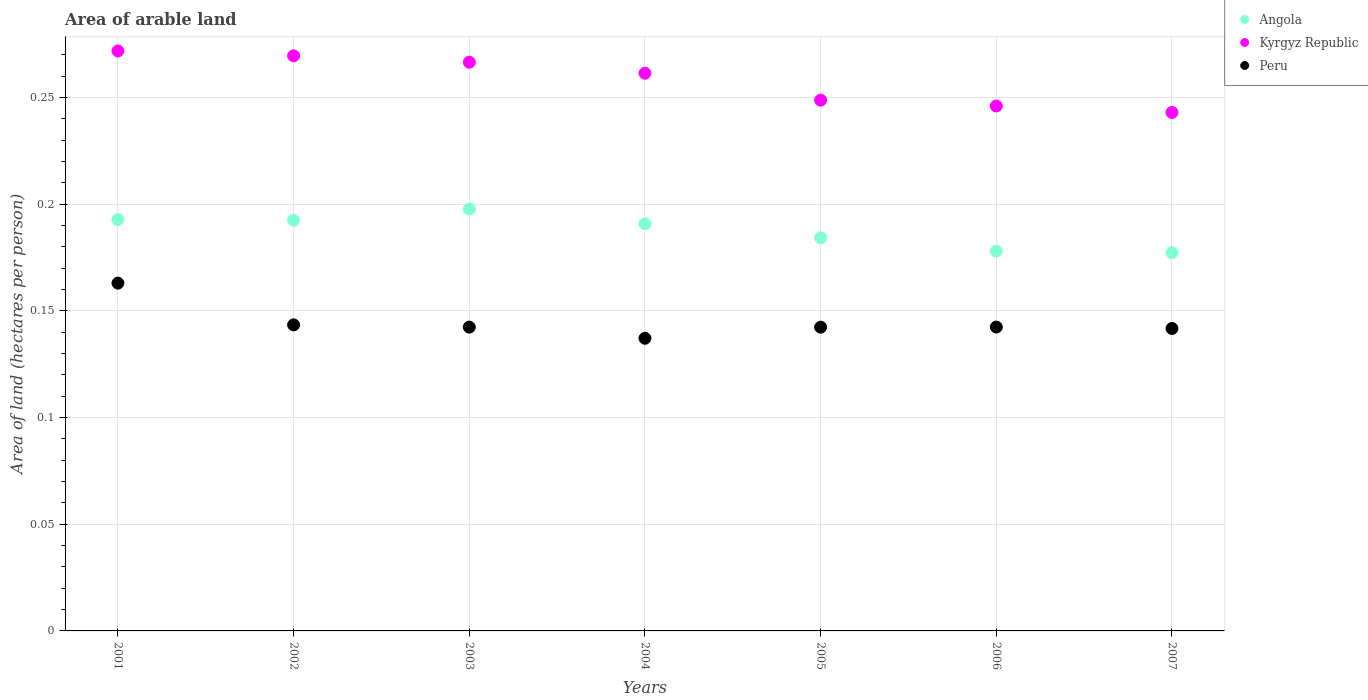What is the total arable land in Angola in 2007?
Offer a very short reply. 0.18. Across all years, what is the maximum total arable land in Peru?
Offer a terse response. 0.16. Across all years, what is the minimum total arable land in Kyrgyz Republic?
Ensure brevity in your answer.  0.24. What is the total total arable land in Angola in the graph?
Offer a very short reply. 1.31. What is the difference between the total arable land in Peru in 2002 and that in 2007?
Your answer should be compact. 0. What is the difference between the total arable land in Peru in 2006 and the total arable land in Kyrgyz Republic in 2005?
Offer a terse response. -0.11. What is the average total arable land in Kyrgyz Republic per year?
Keep it short and to the point. 0.26. In the year 2004, what is the difference between the total arable land in Kyrgyz Republic and total arable land in Angola?
Provide a short and direct response. 0.07. What is the ratio of the total arable land in Kyrgyz Republic in 2005 to that in 2006?
Your response must be concise. 1.01. What is the difference between the highest and the second highest total arable land in Kyrgyz Republic?
Your answer should be very brief. 0. What is the difference between the highest and the lowest total arable land in Kyrgyz Republic?
Your answer should be compact. 0.03. Is the sum of the total arable land in Angola in 2002 and 2004 greater than the maximum total arable land in Kyrgyz Republic across all years?
Give a very brief answer. Yes. Does the total arable land in Kyrgyz Republic monotonically increase over the years?
Your response must be concise. No. Is the total arable land in Peru strictly greater than the total arable land in Kyrgyz Republic over the years?
Keep it short and to the point. No. Is the total arable land in Angola strictly less than the total arable land in Kyrgyz Republic over the years?
Keep it short and to the point. Yes. Does the graph contain grids?
Your answer should be compact. Yes. Where does the legend appear in the graph?
Make the answer very short. Top right. How many legend labels are there?
Ensure brevity in your answer.  3. What is the title of the graph?
Offer a very short reply. Area of arable land. What is the label or title of the X-axis?
Provide a short and direct response. Years. What is the label or title of the Y-axis?
Ensure brevity in your answer.  Area of land (hectares per person). What is the Area of land (hectares per person) in Angola in 2001?
Your response must be concise. 0.19. What is the Area of land (hectares per person) of Kyrgyz Republic in 2001?
Give a very brief answer. 0.27. What is the Area of land (hectares per person) of Peru in 2001?
Ensure brevity in your answer.  0.16. What is the Area of land (hectares per person) of Angola in 2002?
Ensure brevity in your answer.  0.19. What is the Area of land (hectares per person) of Kyrgyz Republic in 2002?
Your answer should be very brief. 0.27. What is the Area of land (hectares per person) of Peru in 2002?
Provide a short and direct response. 0.14. What is the Area of land (hectares per person) of Angola in 2003?
Your answer should be very brief. 0.2. What is the Area of land (hectares per person) in Kyrgyz Republic in 2003?
Your response must be concise. 0.27. What is the Area of land (hectares per person) of Peru in 2003?
Your response must be concise. 0.14. What is the Area of land (hectares per person) of Angola in 2004?
Keep it short and to the point. 0.19. What is the Area of land (hectares per person) of Kyrgyz Republic in 2004?
Your answer should be compact. 0.26. What is the Area of land (hectares per person) in Peru in 2004?
Ensure brevity in your answer.  0.14. What is the Area of land (hectares per person) in Angola in 2005?
Give a very brief answer. 0.18. What is the Area of land (hectares per person) of Kyrgyz Republic in 2005?
Provide a succinct answer. 0.25. What is the Area of land (hectares per person) of Peru in 2005?
Your answer should be compact. 0.14. What is the Area of land (hectares per person) of Angola in 2006?
Provide a succinct answer. 0.18. What is the Area of land (hectares per person) in Kyrgyz Republic in 2006?
Provide a short and direct response. 0.25. What is the Area of land (hectares per person) in Peru in 2006?
Keep it short and to the point. 0.14. What is the Area of land (hectares per person) in Angola in 2007?
Provide a succinct answer. 0.18. What is the Area of land (hectares per person) in Kyrgyz Republic in 2007?
Your answer should be very brief. 0.24. What is the Area of land (hectares per person) in Peru in 2007?
Provide a short and direct response. 0.14. Across all years, what is the maximum Area of land (hectares per person) of Angola?
Your answer should be compact. 0.2. Across all years, what is the maximum Area of land (hectares per person) of Kyrgyz Republic?
Your response must be concise. 0.27. Across all years, what is the maximum Area of land (hectares per person) of Peru?
Your response must be concise. 0.16. Across all years, what is the minimum Area of land (hectares per person) of Angola?
Ensure brevity in your answer.  0.18. Across all years, what is the minimum Area of land (hectares per person) in Kyrgyz Republic?
Offer a very short reply. 0.24. Across all years, what is the minimum Area of land (hectares per person) in Peru?
Keep it short and to the point. 0.14. What is the total Area of land (hectares per person) of Angola in the graph?
Ensure brevity in your answer.  1.31. What is the total Area of land (hectares per person) of Kyrgyz Republic in the graph?
Ensure brevity in your answer.  1.81. What is the total Area of land (hectares per person) in Peru in the graph?
Ensure brevity in your answer.  1.01. What is the difference between the Area of land (hectares per person) in Kyrgyz Republic in 2001 and that in 2002?
Offer a very short reply. 0. What is the difference between the Area of land (hectares per person) in Peru in 2001 and that in 2002?
Your answer should be compact. 0.02. What is the difference between the Area of land (hectares per person) in Angola in 2001 and that in 2003?
Give a very brief answer. -0. What is the difference between the Area of land (hectares per person) of Kyrgyz Republic in 2001 and that in 2003?
Make the answer very short. 0.01. What is the difference between the Area of land (hectares per person) of Peru in 2001 and that in 2003?
Provide a short and direct response. 0.02. What is the difference between the Area of land (hectares per person) of Angola in 2001 and that in 2004?
Keep it short and to the point. 0. What is the difference between the Area of land (hectares per person) in Kyrgyz Republic in 2001 and that in 2004?
Your response must be concise. 0.01. What is the difference between the Area of land (hectares per person) in Peru in 2001 and that in 2004?
Provide a short and direct response. 0.03. What is the difference between the Area of land (hectares per person) of Angola in 2001 and that in 2005?
Your response must be concise. 0.01. What is the difference between the Area of land (hectares per person) of Kyrgyz Republic in 2001 and that in 2005?
Ensure brevity in your answer.  0.02. What is the difference between the Area of land (hectares per person) of Peru in 2001 and that in 2005?
Your answer should be compact. 0.02. What is the difference between the Area of land (hectares per person) of Angola in 2001 and that in 2006?
Give a very brief answer. 0.01. What is the difference between the Area of land (hectares per person) of Kyrgyz Republic in 2001 and that in 2006?
Ensure brevity in your answer.  0.03. What is the difference between the Area of land (hectares per person) in Peru in 2001 and that in 2006?
Offer a very short reply. 0.02. What is the difference between the Area of land (hectares per person) of Angola in 2001 and that in 2007?
Offer a very short reply. 0.02. What is the difference between the Area of land (hectares per person) of Kyrgyz Republic in 2001 and that in 2007?
Offer a very short reply. 0.03. What is the difference between the Area of land (hectares per person) in Peru in 2001 and that in 2007?
Provide a succinct answer. 0.02. What is the difference between the Area of land (hectares per person) in Angola in 2002 and that in 2003?
Keep it short and to the point. -0.01. What is the difference between the Area of land (hectares per person) of Kyrgyz Republic in 2002 and that in 2003?
Make the answer very short. 0. What is the difference between the Area of land (hectares per person) of Angola in 2002 and that in 2004?
Offer a very short reply. 0. What is the difference between the Area of land (hectares per person) of Kyrgyz Republic in 2002 and that in 2004?
Your answer should be compact. 0.01. What is the difference between the Area of land (hectares per person) in Peru in 2002 and that in 2004?
Offer a terse response. 0.01. What is the difference between the Area of land (hectares per person) of Angola in 2002 and that in 2005?
Your answer should be very brief. 0.01. What is the difference between the Area of land (hectares per person) of Kyrgyz Republic in 2002 and that in 2005?
Your answer should be very brief. 0.02. What is the difference between the Area of land (hectares per person) in Peru in 2002 and that in 2005?
Offer a very short reply. 0. What is the difference between the Area of land (hectares per person) of Angola in 2002 and that in 2006?
Keep it short and to the point. 0.01. What is the difference between the Area of land (hectares per person) in Kyrgyz Republic in 2002 and that in 2006?
Your response must be concise. 0.02. What is the difference between the Area of land (hectares per person) in Angola in 2002 and that in 2007?
Make the answer very short. 0.02. What is the difference between the Area of land (hectares per person) in Kyrgyz Republic in 2002 and that in 2007?
Give a very brief answer. 0.03. What is the difference between the Area of land (hectares per person) of Peru in 2002 and that in 2007?
Your answer should be very brief. 0. What is the difference between the Area of land (hectares per person) of Angola in 2003 and that in 2004?
Provide a short and direct response. 0.01. What is the difference between the Area of land (hectares per person) of Kyrgyz Republic in 2003 and that in 2004?
Provide a short and direct response. 0.01. What is the difference between the Area of land (hectares per person) of Peru in 2003 and that in 2004?
Make the answer very short. 0.01. What is the difference between the Area of land (hectares per person) in Angola in 2003 and that in 2005?
Your answer should be compact. 0.01. What is the difference between the Area of land (hectares per person) of Kyrgyz Republic in 2003 and that in 2005?
Your answer should be very brief. 0.02. What is the difference between the Area of land (hectares per person) of Angola in 2003 and that in 2006?
Your answer should be very brief. 0.02. What is the difference between the Area of land (hectares per person) in Kyrgyz Republic in 2003 and that in 2006?
Ensure brevity in your answer.  0.02. What is the difference between the Area of land (hectares per person) in Angola in 2003 and that in 2007?
Your answer should be very brief. 0.02. What is the difference between the Area of land (hectares per person) of Kyrgyz Republic in 2003 and that in 2007?
Offer a terse response. 0.02. What is the difference between the Area of land (hectares per person) of Peru in 2003 and that in 2007?
Give a very brief answer. 0. What is the difference between the Area of land (hectares per person) of Angola in 2004 and that in 2005?
Make the answer very short. 0.01. What is the difference between the Area of land (hectares per person) of Kyrgyz Republic in 2004 and that in 2005?
Keep it short and to the point. 0.01. What is the difference between the Area of land (hectares per person) of Peru in 2004 and that in 2005?
Offer a very short reply. -0.01. What is the difference between the Area of land (hectares per person) of Angola in 2004 and that in 2006?
Ensure brevity in your answer.  0.01. What is the difference between the Area of land (hectares per person) in Kyrgyz Republic in 2004 and that in 2006?
Your answer should be very brief. 0.02. What is the difference between the Area of land (hectares per person) of Peru in 2004 and that in 2006?
Your answer should be very brief. -0.01. What is the difference between the Area of land (hectares per person) of Angola in 2004 and that in 2007?
Your answer should be compact. 0.01. What is the difference between the Area of land (hectares per person) in Kyrgyz Republic in 2004 and that in 2007?
Provide a succinct answer. 0.02. What is the difference between the Area of land (hectares per person) in Peru in 2004 and that in 2007?
Keep it short and to the point. -0. What is the difference between the Area of land (hectares per person) of Angola in 2005 and that in 2006?
Your response must be concise. 0.01. What is the difference between the Area of land (hectares per person) in Kyrgyz Republic in 2005 and that in 2006?
Your response must be concise. 0. What is the difference between the Area of land (hectares per person) in Peru in 2005 and that in 2006?
Make the answer very short. -0. What is the difference between the Area of land (hectares per person) in Angola in 2005 and that in 2007?
Provide a succinct answer. 0.01. What is the difference between the Area of land (hectares per person) in Kyrgyz Republic in 2005 and that in 2007?
Your answer should be compact. 0.01. What is the difference between the Area of land (hectares per person) in Peru in 2005 and that in 2007?
Your answer should be compact. 0. What is the difference between the Area of land (hectares per person) of Angola in 2006 and that in 2007?
Your answer should be very brief. 0. What is the difference between the Area of land (hectares per person) of Kyrgyz Republic in 2006 and that in 2007?
Offer a very short reply. 0. What is the difference between the Area of land (hectares per person) in Peru in 2006 and that in 2007?
Offer a terse response. 0. What is the difference between the Area of land (hectares per person) in Angola in 2001 and the Area of land (hectares per person) in Kyrgyz Republic in 2002?
Offer a terse response. -0.08. What is the difference between the Area of land (hectares per person) of Angola in 2001 and the Area of land (hectares per person) of Peru in 2002?
Give a very brief answer. 0.05. What is the difference between the Area of land (hectares per person) of Kyrgyz Republic in 2001 and the Area of land (hectares per person) of Peru in 2002?
Keep it short and to the point. 0.13. What is the difference between the Area of land (hectares per person) in Angola in 2001 and the Area of land (hectares per person) in Kyrgyz Republic in 2003?
Provide a short and direct response. -0.07. What is the difference between the Area of land (hectares per person) in Angola in 2001 and the Area of land (hectares per person) in Peru in 2003?
Keep it short and to the point. 0.05. What is the difference between the Area of land (hectares per person) in Kyrgyz Republic in 2001 and the Area of land (hectares per person) in Peru in 2003?
Your response must be concise. 0.13. What is the difference between the Area of land (hectares per person) in Angola in 2001 and the Area of land (hectares per person) in Kyrgyz Republic in 2004?
Offer a terse response. -0.07. What is the difference between the Area of land (hectares per person) of Angola in 2001 and the Area of land (hectares per person) of Peru in 2004?
Ensure brevity in your answer.  0.06. What is the difference between the Area of land (hectares per person) in Kyrgyz Republic in 2001 and the Area of land (hectares per person) in Peru in 2004?
Your response must be concise. 0.13. What is the difference between the Area of land (hectares per person) in Angola in 2001 and the Area of land (hectares per person) in Kyrgyz Republic in 2005?
Your response must be concise. -0.06. What is the difference between the Area of land (hectares per person) in Angola in 2001 and the Area of land (hectares per person) in Peru in 2005?
Provide a succinct answer. 0.05. What is the difference between the Area of land (hectares per person) in Kyrgyz Republic in 2001 and the Area of land (hectares per person) in Peru in 2005?
Make the answer very short. 0.13. What is the difference between the Area of land (hectares per person) of Angola in 2001 and the Area of land (hectares per person) of Kyrgyz Republic in 2006?
Provide a short and direct response. -0.05. What is the difference between the Area of land (hectares per person) of Angola in 2001 and the Area of land (hectares per person) of Peru in 2006?
Your answer should be compact. 0.05. What is the difference between the Area of land (hectares per person) of Kyrgyz Republic in 2001 and the Area of land (hectares per person) of Peru in 2006?
Provide a short and direct response. 0.13. What is the difference between the Area of land (hectares per person) in Angola in 2001 and the Area of land (hectares per person) in Kyrgyz Republic in 2007?
Provide a succinct answer. -0.05. What is the difference between the Area of land (hectares per person) of Angola in 2001 and the Area of land (hectares per person) of Peru in 2007?
Provide a short and direct response. 0.05. What is the difference between the Area of land (hectares per person) of Kyrgyz Republic in 2001 and the Area of land (hectares per person) of Peru in 2007?
Your response must be concise. 0.13. What is the difference between the Area of land (hectares per person) of Angola in 2002 and the Area of land (hectares per person) of Kyrgyz Republic in 2003?
Give a very brief answer. -0.07. What is the difference between the Area of land (hectares per person) of Angola in 2002 and the Area of land (hectares per person) of Peru in 2003?
Ensure brevity in your answer.  0.05. What is the difference between the Area of land (hectares per person) in Kyrgyz Republic in 2002 and the Area of land (hectares per person) in Peru in 2003?
Offer a very short reply. 0.13. What is the difference between the Area of land (hectares per person) in Angola in 2002 and the Area of land (hectares per person) in Kyrgyz Republic in 2004?
Your response must be concise. -0.07. What is the difference between the Area of land (hectares per person) in Angola in 2002 and the Area of land (hectares per person) in Peru in 2004?
Offer a terse response. 0.06. What is the difference between the Area of land (hectares per person) of Kyrgyz Republic in 2002 and the Area of land (hectares per person) of Peru in 2004?
Offer a very short reply. 0.13. What is the difference between the Area of land (hectares per person) in Angola in 2002 and the Area of land (hectares per person) in Kyrgyz Republic in 2005?
Provide a short and direct response. -0.06. What is the difference between the Area of land (hectares per person) of Angola in 2002 and the Area of land (hectares per person) of Peru in 2005?
Your answer should be very brief. 0.05. What is the difference between the Area of land (hectares per person) in Kyrgyz Republic in 2002 and the Area of land (hectares per person) in Peru in 2005?
Offer a very short reply. 0.13. What is the difference between the Area of land (hectares per person) of Angola in 2002 and the Area of land (hectares per person) of Kyrgyz Republic in 2006?
Give a very brief answer. -0.05. What is the difference between the Area of land (hectares per person) in Angola in 2002 and the Area of land (hectares per person) in Peru in 2006?
Ensure brevity in your answer.  0.05. What is the difference between the Area of land (hectares per person) in Kyrgyz Republic in 2002 and the Area of land (hectares per person) in Peru in 2006?
Provide a succinct answer. 0.13. What is the difference between the Area of land (hectares per person) in Angola in 2002 and the Area of land (hectares per person) in Kyrgyz Republic in 2007?
Ensure brevity in your answer.  -0.05. What is the difference between the Area of land (hectares per person) in Angola in 2002 and the Area of land (hectares per person) in Peru in 2007?
Provide a succinct answer. 0.05. What is the difference between the Area of land (hectares per person) in Kyrgyz Republic in 2002 and the Area of land (hectares per person) in Peru in 2007?
Make the answer very short. 0.13. What is the difference between the Area of land (hectares per person) of Angola in 2003 and the Area of land (hectares per person) of Kyrgyz Republic in 2004?
Make the answer very short. -0.06. What is the difference between the Area of land (hectares per person) in Angola in 2003 and the Area of land (hectares per person) in Peru in 2004?
Make the answer very short. 0.06. What is the difference between the Area of land (hectares per person) of Kyrgyz Republic in 2003 and the Area of land (hectares per person) of Peru in 2004?
Your answer should be very brief. 0.13. What is the difference between the Area of land (hectares per person) of Angola in 2003 and the Area of land (hectares per person) of Kyrgyz Republic in 2005?
Provide a succinct answer. -0.05. What is the difference between the Area of land (hectares per person) of Angola in 2003 and the Area of land (hectares per person) of Peru in 2005?
Offer a very short reply. 0.06. What is the difference between the Area of land (hectares per person) of Kyrgyz Republic in 2003 and the Area of land (hectares per person) of Peru in 2005?
Make the answer very short. 0.12. What is the difference between the Area of land (hectares per person) in Angola in 2003 and the Area of land (hectares per person) in Kyrgyz Republic in 2006?
Your response must be concise. -0.05. What is the difference between the Area of land (hectares per person) in Angola in 2003 and the Area of land (hectares per person) in Peru in 2006?
Provide a succinct answer. 0.06. What is the difference between the Area of land (hectares per person) of Kyrgyz Republic in 2003 and the Area of land (hectares per person) of Peru in 2006?
Keep it short and to the point. 0.12. What is the difference between the Area of land (hectares per person) in Angola in 2003 and the Area of land (hectares per person) in Kyrgyz Republic in 2007?
Your response must be concise. -0.05. What is the difference between the Area of land (hectares per person) in Angola in 2003 and the Area of land (hectares per person) in Peru in 2007?
Your answer should be compact. 0.06. What is the difference between the Area of land (hectares per person) of Kyrgyz Republic in 2003 and the Area of land (hectares per person) of Peru in 2007?
Make the answer very short. 0.12. What is the difference between the Area of land (hectares per person) in Angola in 2004 and the Area of land (hectares per person) in Kyrgyz Republic in 2005?
Give a very brief answer. -0.06. What is the difference between the Area of land (hectares per person) of Angola in 2004 and the Area of land (hectares per person) of Peru in 2005?
Your answer should be compact. 0.05. What is the difference between the Area of land (hectares per person) of Kyrgyz Republic in 2004 and the Area of land (hectares per person) of Peru in 2005?
Your answer should be compact. 0.12. What is the difference between the Area of land (hectares per person) in Angola in 2004 and the Area of land (hectares per person) in Kyrgyz Republic in 2006?
Your answer should be compact. -0.06. What is the difference between the Area of land (hectares per person) in Angola in 2004 and the Area of land (hectares per person) in Peru in 2006?
Make the answer very short. 0.05. What is the difference between the Area of land (hectares per person) of Kyrgyz Republic in 2004 and the Area of land (hectares per person) of Peru in 2006?
Ensure brevity in your answer.  0.12. What is the difference between the Area of land (hectares per person) in Angola in 2004 and the Area of land (hectares per person) in Kyrgyz Republic in 2007?
Provide a succinct answer. -0.05. What is the difference between the Area of land (hectares per person) in Angola in 2004 and the Area of land (hectares per person) in Peru in 2007?
Your answer should be very brief. 0.05. What is the difference between the Area of land (hectares per person) in Kyrgyz Republic in 2004 and the Area of land (hectares per person) in Peru in 2007?
Give a very brief answer. 0.12. What is the difference between the Area of land (hectares per person) in Angola in 2005 and the Area of land (hectares per person) in Kyrgyz Republic in 2006?
Your answer should be compact. -0.06. What is the difference between the Area of land (hectares per person) in Angola in 2005 and the Area of land (hectares per person) in Peru in 2006?
Your response must be concise. 0.04. What is the difference between the Area of land (hectares per person) in Kyrgyz Republic in 2005 and the Area of land (hectares per person) in Peru in 2006?
Give a very brief answer. 0.11. What is the difference between the Area of land (hectares per person) of Angola in 2005 and the Area of land (hectares per person) of Kyrgyz Republic in 2007?
Your answer should be compact. -0.06. What is the difference between the Area of land (hectares per person) of Angola in 2005 and the Area of land (hectares per person) of Peru in 2007?
Offer a very short reply. 0.04. What is the difference between the Area of land (hectares per person) of Kyrgyz Republic in 2005 and the Area of land (hectares per person) of Peru in 2007?
Keep it short and to the point. 0.11. What is the difference between the Area of land (hectares per person) of Angola in 2006 and the Area of land (hectares per person) of Kyrgyz Republic in 2007?
Offer a terse response. -0.07. What is the difference between the Area of land (hectares per person) of Angola in 2006 and the Area of land (hectares per person) of Peru in 2007?
Offer a terse response. 0.04. What is the difference between the Area of land (hectares per person) of Kyrgyz Republic in 2006 and the Area of land (hectares per person) of Peru in 2007?
Your response must be concise. 0.1. What is the average Area of land (hectares per person) in Angola per year?
Your answer should be very brief. 0.19. What is the average Area of land (hectares per person) of Kyrgyz Republic per year?
Give a very brief answer. 0.26. What is the average Area of land (hectares per person) in Peru per year?
Your response must be concise. 0.14. In the year 2001, what is the difference between the Area of land (hectares per person) in Angola and Area of land (hectares per person) in Kyrgyz Republic?
Offer a very short reply. -0.08. In the year 2001, what is the difference between the Area of land (hectares per person) in Angola and Area of land (hectares per person) in Peru?
Offer a very short reply. 0.03. In the year 2001, what is the difference between the Area of land (hectares per person) in Kyrgyz Republic and Area of land (hectares per person) in Peru?
Offer a very short reply. 0.11. In the year 2002, what is the difference between the Area of land (hectares per person) of Angola and Area of land (hectares per person) of Kyrgyz Republic?
Give a very brief answer. -0.08. In the year 2002, what is the difference between the Area of land (hectares per person) of Angola and Area of land (hectares per person) of Peru?
Provide a succinct answer. 0.05. In the year 2002, what is the difference between the Area of land (hectares per person) in Kyrgyz Republic and Area of land (hectares per person) in Peru?
Give a very brief answer. 0.13. In the year 2003, what is the difference between the Area of land (hectares per person) in Angola and Area of land (hectares per person) in Kyrgyz Republic?
Offer a terse response. -0.07. In the year 2003, what is the difference between the Area of land (hectares per person) of Angola and Area of land (hectares per person) of Peru?
Provide a short and direct response. 0.06. In the year 2003, what is the difference between the Area of land (hectares per person) of Kyrgyz Republic and Area of land (hectares per person) of Peru?
Your answer should be very brief. 0.12. In the year 2004, what is the difference between the Area of land (hectares per person) of Angola and Area of land (hectares per person) of Kyrgyz Republic?
Make the answer very short. -0.07. In the year 2004, what is the difference between the Area of land (hectares per person) in Angola and Area of land (hectares per person) in Peru?
Your response must be concise. 0.05. In the year 2004, what is the difference between the Area of land (hectares per person) of Kyrgyz Republic and Area of land (hectares per person) of Peru?
Offer a very short reply. 0.12. In the year 2005, what is the difference between the Area of land (hectares per person) in Angola and Area of land (hectares per person) in Kyrgyz Republic?
Ensure brevity in your answer.  -0.06. In the year 2005, what is the difference between the Area of land (hectares per person) in Angola and Area of land (hectares per person) in Peru?
Give a very brief answer. 0.04. In the year 2005, what is the difference between the Area of land (hectares per person) in Kyrgyz Republic and Area of land (hectares per person) in Peru?
Your response must be concise. 0.11. In the year 2006, what is the difference between the Area of land (hectares per person) in Angola and Area of land (hectares per person) in Kyrgyz Republic?
Keep it short and to the point. -0.07. In the year 2006, what is the difference between the Area of land (hectares per person) in Angola and Area of land (hectares per person) in Peru?
Provide a short and direct response. 0.04. In the year 2006, what is the difference between the Area of land (hectares per person) in Kyrgyz Republic and Area of land (hectares per person) in Peru?
Your answer should be compact. 0.1. In the year 2007, what is the difference between the Area of land (hectares per person) of Angola and Area of land (hectares per person) of Kyrgyz Republic?
Ensure brevity in your answer.  -0.07. In the year 2007, what is the difference between the Area of land (hectares per person) in Angola and Area of land (hectares per person) in Peru?
Offer a very short reply. 0.04. In the year 2007, what is the difference between the Area of land (hectares per person) in Kyrgyz Republic and Area of land (hectares per person) in Peru?
Provide a succinct answer. 0.1. What is the ratio of the Area of land (hectares per person) in Kyrgyz Republic in 2001 to that in 2002?
Your response must be concise. 1.01. What is the ratio of the Area of land (hectares per person) in Peru in 2001 to that in 2002?
Your response must be concise. 1.14. What is the ratio of the Area of land (hectares per person) in Angola in 2001 to that in 2003?
Provide a short and direct response. 0.97. What is the ratio of the Area of land (hectares per person) in Kyrgyz Republic in 2001 to that in 2003?
Offer a terse response. 1.02. What is the ratio of the Area of land (hectares per person) of Peru in 2001 to that in 2003?
Provide a short and direct response. 1.14. What is the ratio of the Area of land (hectares per person) of Angola in 2001 to that in 2004?
Your answer should be compact. 1.01. What is the ratio of the Area of land (hectares per person) in Peru in 2001 to that in 2004?
Ensure brevity in your answer.  1.19. What is the ratio of the Area of land (hectares per person) of Angola in 2001 to that in 2005?
Your response must be concise. 1.05. What is the ratio of the Area of land (hectares per person) in Kyrgyz Republic in 2001 to that in 2005?
Keep it short and to the point. 1.09. What is the ratio of the Area of land (hectares per person) in Peru in 2001 to that in 2005?
Provide a succinct answer. 1.15. What is the ratio of the Area of land (hectares per person) of Angola in 2001 to that in 2006?
Your response must be concise. 1.08. What is the ratio of the Area of land (hectares per person) in Kyrgyz Republic in 2001 to that in 2006?
Your answer should be compact. 1.1. What is the ratio of the Area of land (hectares per person) in Peru in 2001 to that in 2006?
Your response must be concise. 1.14. What is the ratio of the Area of land (hectares per person) of Angola in 2001 to that in 2007?
Provide a succinct answer. 1.09. What is the ratio of the Area of land (hectares per person) in Kyrgyz Republic in 2001 to that in 2007?
Keep it short and to the point. 1.12. What is the ratio of the Area of land (hectares per person) in Peru in 2001 to that in 2007?
Keep it short and to the point. 1.15. What is the ratio of the Area of land (hectares per person) in Angola in 2002 to that in 2003?
Offer a very short reply. 0.97. What is the ratio of the Area of land (hectares per person) in Kyrgyz Republic in 2002 to that in 2003?
Your response must be concise. 1.01. What is the ratio of the Area of land (hectares per person) of Peru in 2002 to that in 2003?
Ensure brevity in your answer.  1.01. What is the ratio of the Area of land (hectares per person) in Angola in 2002 to that in 2004?
Your answer should be compact. 1.01. What is the ratio of the Area of land (hectares per person) in Kyrgyz Republic in 2002 to that in 2004?
Give a very brief answer. 1.03. What is the ratio of the Area of land (hectares per person) of Peru in 2002 to that in 2004?
Offer a very short reply. 1.05. What is the ratio of the Area of land (hectares per person) of Angola in 2002 to that in 2005?
Offer a terse response. 1.04. What is the ratio of the Area of land (hectares per person) of Kyrgyz Republic in 2002 to that in 2005?
Offer a very short reply. 1.08. What is the ratio of the Area of land (hectares per person) in Peru in 2002 to that in 2005?
Your answer should be compact. 1.01. What is the ratio of the Area of land (hectares per person) of Angola in 2002 to that in 2006?
Keep it short and to the point. 1.08. What is the ratio of the Area of land (hectares per person) in Kyrgyz Republic in 2002 to that in 2006?
Offer a very short reply. 1.1. What is the ratio of the Area of land (hectares per person) of Peru in 2002 to that in 2006?
Give a very brief answer. 1.01. What is the ratio of the Area of land (hectares per person) in Angola in 2002 to that in 2007?
Ensure brevity in your answer.  1.09. What is the ratio of the Area of land (hectares per person) of Kyrgyz Republic in 2002 to that in 2007?
Offer a terse response. 1.11. What is the ratio of the Area of land (hectares per person) of Peru in 2002 to that in 2007?
Provide a succinct answer. 1.01. What is the ratio of the Area of land (hectares per person) in Angola in 2003 to that in 2004?
Offer a very short reply. 1.04. What is the ratio of the Area of land (hectares per person) in Kyrgyz Republic in 2003 to that in 2004?
Offer a very short reply. 1.02. What is the ratio of the Area of land (hectares per person) of Peru in 2003 to that in 2004?
Your response must be concise. 1.04. What is the ratio of the Area of land (hectares per person) in Angola in 2003 to that in 2005?
Your response must be concise. 1.07. What is the ratio of the Area of land (hectares per person) in Kyrgyz Republic in 2003 to that in 2005?
Offer a very short reply. 1.07. What is the ratio of the Area of land (hectares per person) in Peru in 2003 to that in 2005?
Provide a succinct answer. 1. What is the ratio of the Area of land (hectares per person) of Angola in 2003 to that in 2006?
Keep it short and to the point. 1.11. What is the ratio of the Area of land (hectares per person) of Kyrgyz Republic in 2003 to that in 2006?
Your response must be concise. 1.08. What is the ratio of the Area of land (hectares per person) of Angola in 2003 to that in 2007?
Give a very brief answer. 1.12. What is the ratio of the Area of land (hectares per person) of Kyrgyz Republic in 2003 to that in 2007?
Provide a succinct answer. 1.1. What is the ratio of the Area of land (hectares per person) of Angola in 2004 to that in 2005?
Provide a succinct answer. 1.04. What is the ratio of the Area of land (hectares per person) of Kyrgyz Republic in 2004 to that in 2005?
Offer a terse response. 1.05. What is the ratio of the Area of land (hectares per person) of Peru in 2004 to that in 2005?
Ensure brevity in your answer.  0.96. What is the ratio of the Area of land (hectares per person) in Angola in 2004 to that in 2006?
Offer a terse response. 1.07. What is the ratio of the Area of land (hectares per person) in Kyrgyz Republic in 2004 to that in 2006?
Ensure brevity in your answer.  1.06. What is the ratio of the Area of land (hectares per person) of Peru in 2004 to that in 2006?
Provide a short and direct response. 0.96. What is the ratio of the Area of land (hectares per person) of Angola in 2004 to that in 2007?
Provide a succinct answer. 1.08. What is the ratio of the Area of land (hectares per person) in Kyrgyz Republic in 2004 to that in 2007?
Make the answer very short. 1.08. What is the ratio of the Area of land (hectares per person) in Peru in 2004 to that in 2007?
Give a very brief answer. 0.97. What is the ratio of the Area of land (hectares per person) of Angola in 2005 to that in 2006?
Provide a short and direct response. 1.04. What is the ratio of the Area of land (hectares per person) in Peru in 2005 to that in 2006?
Your response must be concise. 1. What is the ratio of the Area of land (hectares per person) of Angola in 2005 to that in 2007?
Offer a terse response. 1.04. What is the ratio of the Area of land (hectares per person) of Kyrgyz Republic in 2005 to that in 2007?
Your response must be concise. 1.02. What is the ratio of the Area of land (hectares per person) of Peru in 2005 to that in 2007?
Make the answer very short. 1. What is the ratio of the Area of land (hectares per person) of Kyrgyz Republic in 2006 to that in 2007?
Keep it short and to the point. 1.01. What is the difference between the highest and the second highest Area of land (hectares per person) in Angola?
Make the answer very short. 0. What is the difference between the highest and the second highest Area of land (hectares per person) of Kyrgyz Republic?
Your answer should be compact. 0. What is the difference between the highest and the second highest Area of land (hectares per person) of Peru?
Offer a terse response. 0.02. What is the difference between the highest and the lowest Area of land (hectares per person) of Angola?
Offer a very short reply. 0.02. What is the difference between the highest and the lowest Area of land (hectares per person) of Kyrgyz Republic?
Give a very brief answer. 0.03. What is the difference between the highest and the lowest Area of land (hectares per person) in Peru?
Your answer should be compact. 0.03. 